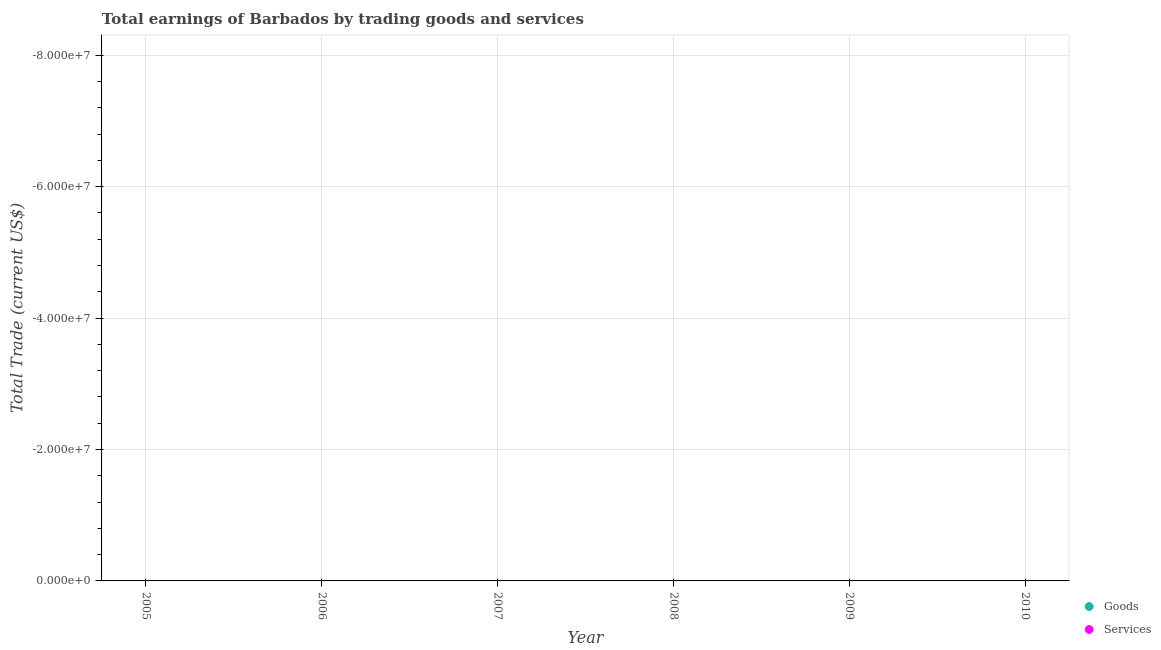How many different coloured dotlines are there?
Offer a terse response. 0. What is the amount earned by trading goods in 2007?
Offer a terse response. 0. Across all years, what is the minimum amount earned by trading goods?
Your answer should be very brief. 0. What is the total amount earned by trading goods in the graph?
Offer a very short reply. 0. In how many years, is the amount earned by trading goods greater than -40000000 US$?
Provide a short and direct response. 0. In how many years, is the amount earned by trading services greater than the average amount earned by trading services taken over all years?
Your answer should be very brief. 0. Is the amount earned by trading services strictly greater than the amount earned by trading goods over the years?
Your response must be concise. Yes. How many dotlines are there?
Offer a very short reply. 0. Are the values on the major ticks of Y-axis written in scientific E-notation?
Provide a succinct answer. Yes. Does the graph contain grids?
Your response must be concise. Yes. Where does the legend appear in the graph?
Offer a very short reply. Bottom right. How many legend labels are there?
Offer a terse response. 2. What is the title of the graph?
Ensure brevity in your answer.  Total earnings of Barbados by trading goods and services. What is the label or title of the Y-axis?
Ensure brevity in your answer.  Total Trade (current US$). What is the Total Trade (current US$) of Services in 2005?
Provide a short and direct response. 0. What is the Total Trade (current US$) in Goods in 2006?
Keep it short and to the point. 0. What is the Total Trade (current US$) in Goods in 2007?
Make the answer very short. 0. What is the Total Trade (current US$) of Services in 2008?
Your answer should be very brief. 0. What is the Total Trade (current US$) in Goods in 2010?
Provide a succinct answer. 0. What is the Total Trade (current US$) of Services in 2010?
Give a very brief answer. 0. What is the total Total Trade (current US$) in Goods in the graph?
Provide a short and direct response. 0. 